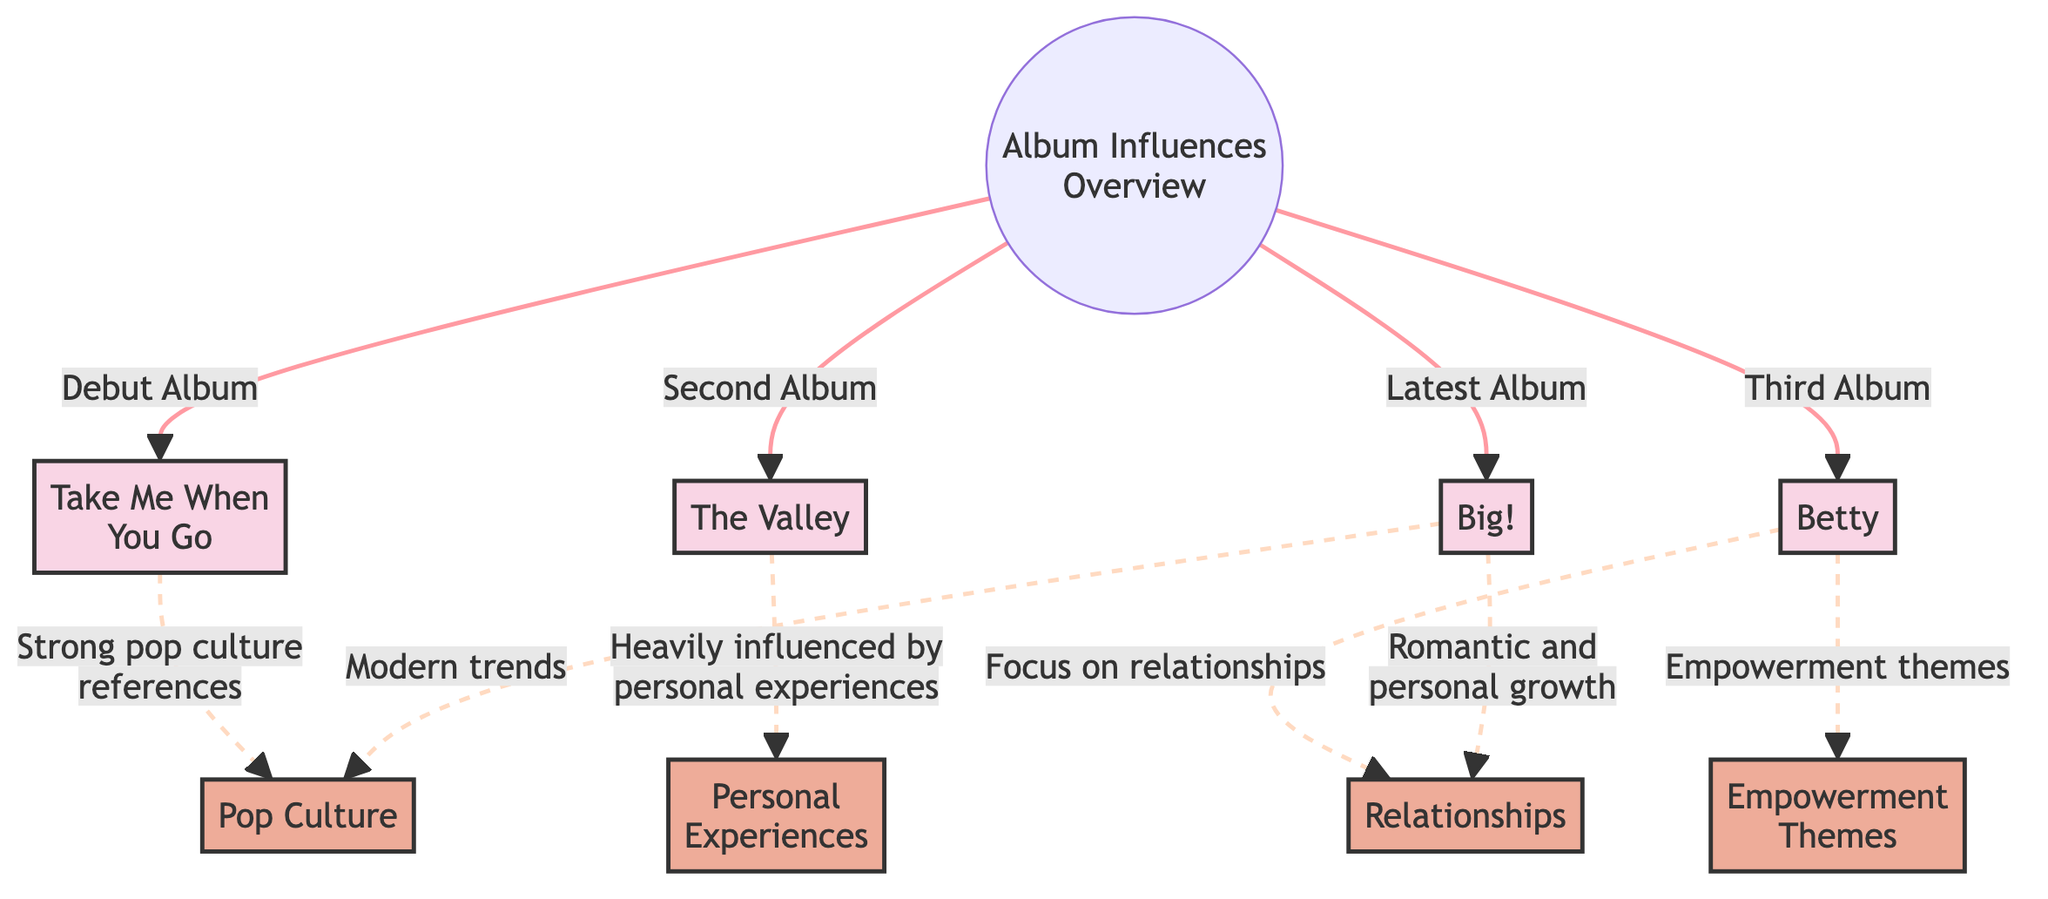What is the first album listed in the diagram? The diagram identifies "Take Me When You Go" as the debut album, which is connected to the main overview node.
Answer: Take Me When You Go How many albums are represented in the diagram? The diagram shows four distinct albums connected to the overview node. They are "Take Me When You Go," "The Valley," "Betty," and "Big!"
Answer: 4 What theme influences the album "Betty"? The diagram indicates that "Betty" is primarily influenced by themes of relationships, as denoted by its connection to the respective influence node.
Answer: Relationships Which album is associated with personal experiences? According to the diagram, "The Valley" is heavily influenced by personal experiences, as indicated by the connection to the influence node.
Answer: The Valley What influence is linked to both the latest album and the album "Big!"? The diagram shows that both "Big!" and the latest album are connected to the influence of romantic and personal growth, highlighting a common theme among them.
Answer: Romantic and personal growth Which album appears to have strong pop culture references? The diagram specifies that "Take Me When You Go" is notably influenced by strong pop culture references as outlined in the influence node's pathway.
Answer: Take Me When You Go What is the connection between "Big!" and modern trends? "Big!" has a direct link to the influence node representing modern trends, indicating its relevance to contemporary cultural elements.
Answer: Modern trends How many influence nodes are presented in the diagram? The diagram illustrates a total of five influence nodes, showing the various thematic elements that shape the lyrics across the albums.
Answer: 5 Which album focuses on empowerment themes? The diagram clearly states that "Betty" is linked to the influence of empowerment themes, showcasing a significant aspect of its lyrical content.
Answer: Betty 